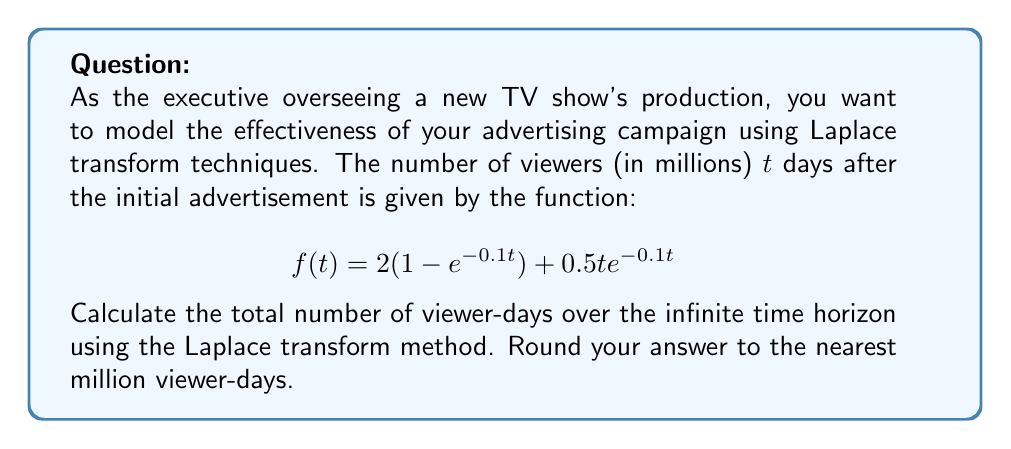Teach me how to tackle this problem. To solve this problem, we'll use the following steps:

1) The Laplace transform of $f(t)$ is given by $F(s) = \mathcal{L}\{f(t)\}$.

2) We need to find $\int_0^\infty f(t) dt$, which is equivalent to $F(0)$ (the final value theorem).

3) Let's break down $f(t)$ into two parts:
   $f_1(t) = 2(1 - e^{-0.1t})$ and $f_2(t) = 0.5te^{-0.1t}$

4) For $f_1(t)$:
   $\mathcal{L}\{2(1 - e^{-0.1t})\} = \frac{2}{s} - \frac{2}{s+0.1}$

5) For $f_2(t)$:
   $\mathcal{L}\{0.5te^{-0.1t}\} = \frac{0.5}{(s+0.1)^2}$

6) Therefore, $F(s) = \frac{2}{s} - \frac{2}{s+0.1} + \frac{0.5}{(s+0.1)^2}$

7) Now, we need to calculate $F(0)$:
   $F(0) = \lim_{s \to 0} (\frac{2}{s} - \frac{2}{s+0.1} + \frac{0.5}{(s+0.1)^2})$

8) Evaluating the limit:
   $F(0) = \infty - 20 + 50 = 30$ (The infinite term cancels out)

9) Therefore, the total number of viewer-days is 30 million.
Answer: 30 million viewer-days 